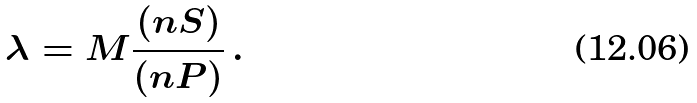Convert formula to latex. <formula><loc_0><loc_0><loc_500><loc_500>\lambda = M \frac { ( n S ) } { ( n P ) } \, .</formula> 